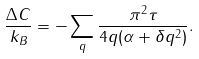Convert formula to latex. <formula><loc_0><loc_0><loc_500><loc_500>\frac { \Delta C } { k _ { B } } = - \sum _ { q } \frac { \pi ^ { 2 } \tau } { 4 q ( \alpha + \delta q ^ { 2 } ) } .</formula> 